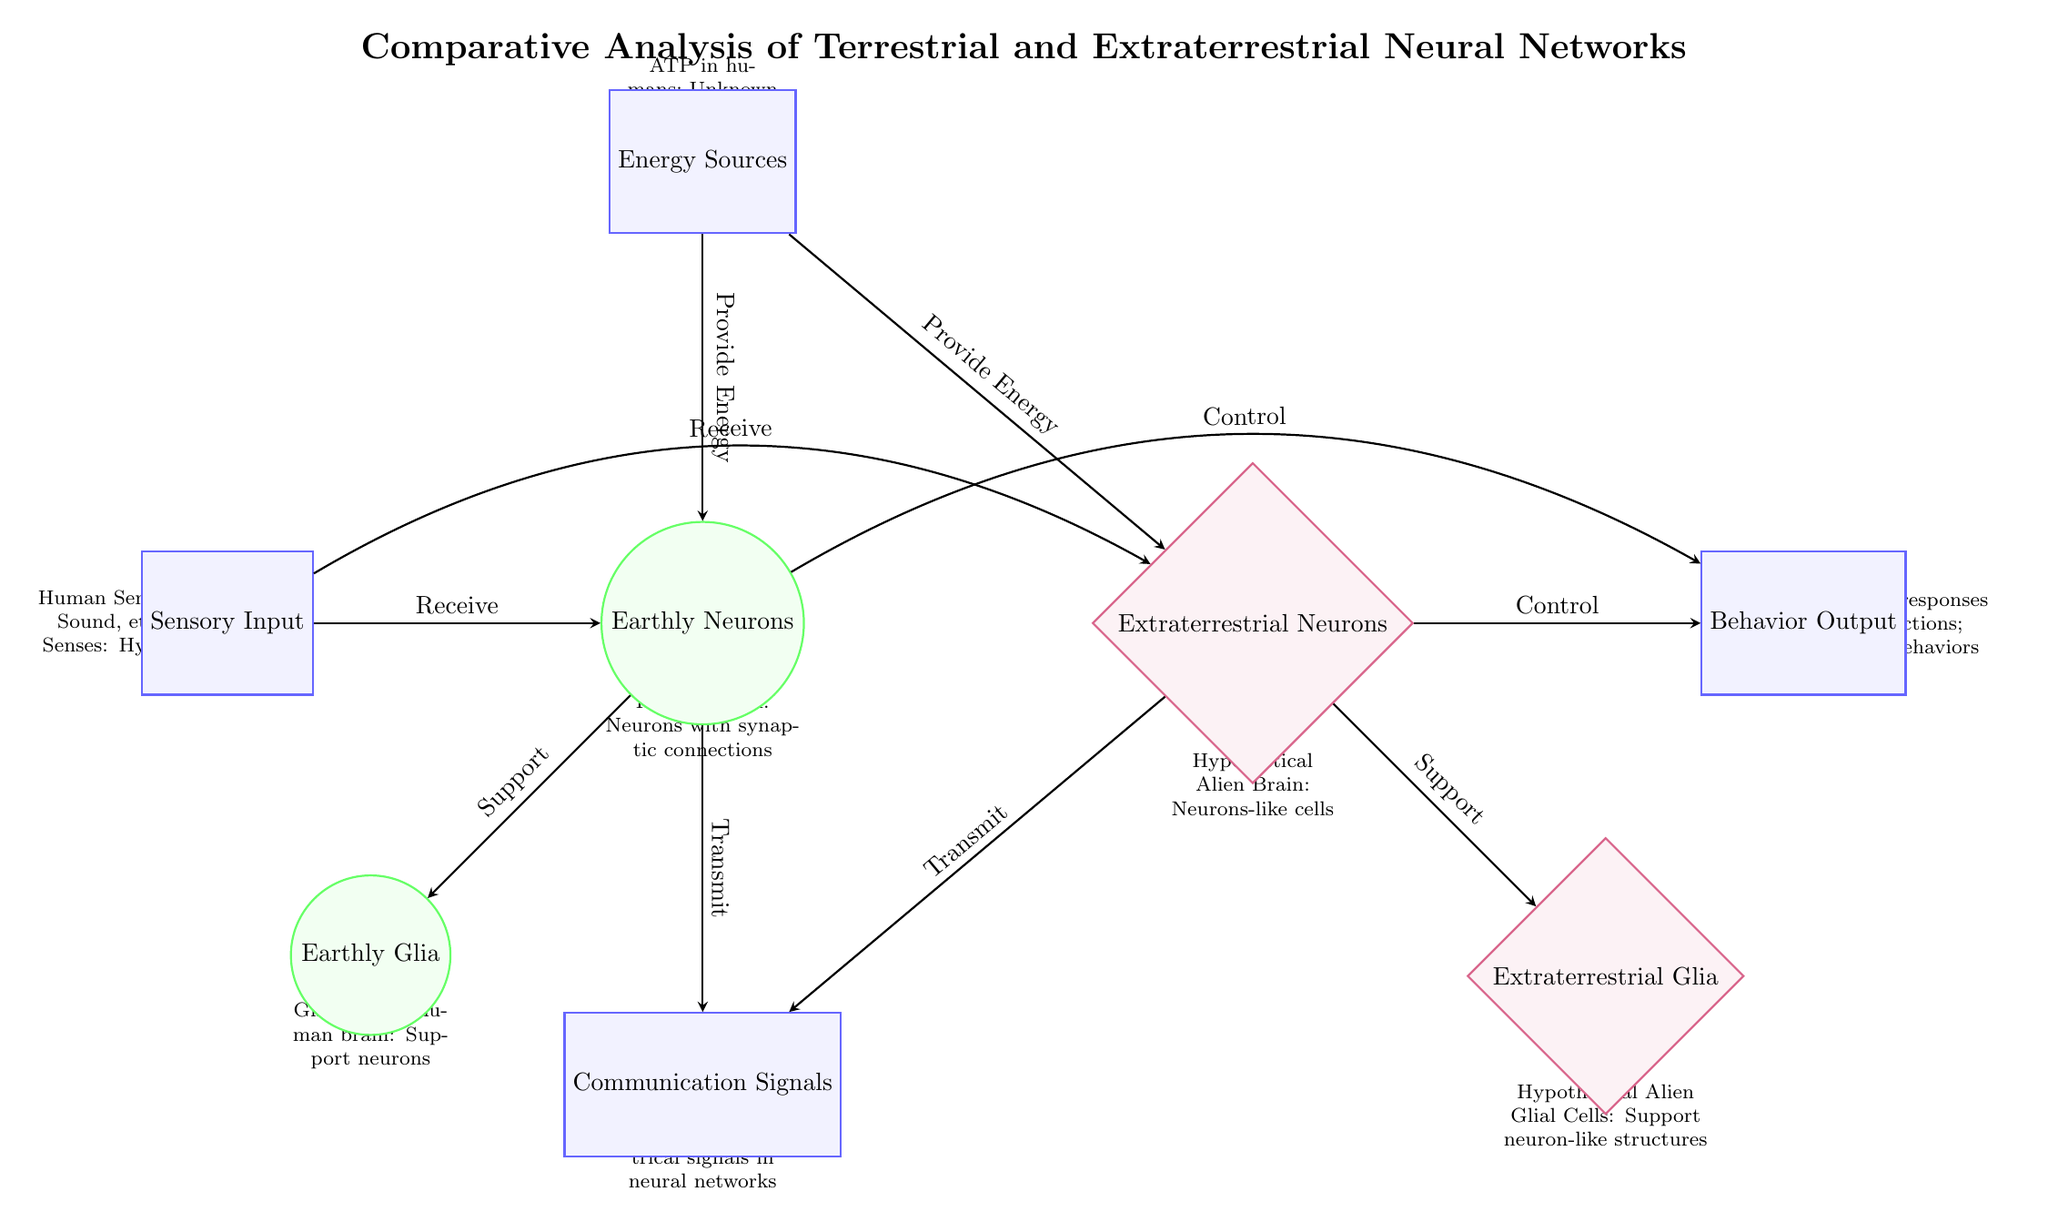What are the two types of neurons depicted in the diagram? The diagram shows two types of neurons: Earthly Neurons and Extraterrestrial Neurons.
Answer: Earthly Neurons, Extraterrestrial Neurons Which node represents the energy sources? The node labeled "Energy Sources" is positioned above the Earthly Neurons node.
Answer: Energy Sources How many support relationships are indicated in the diagram? There are two support relationships: one from Earthly Neurons to Earthly Glia and another from Extraterrestrial Neurons to Extraterrestrial Glia, totaling two.
Answer: 2 What type of input is received by both terrestrial and extraterrestrial neurons? Both types of neurons receive "Sensory Input," as indicated by the edges connecting to both the Earthly Neurons and the Extraterrestrial Neurons.
Answer: Sensory Input What is the primary output behavior of the neurons shown? The primary output behavior is indicated as "Behavior Output," which both neuron types control based on connections leading from them.
Answer: Behavior Output What two components are required for energy provision to both neuron types? Both neuron types require energy sources: "ATP in humans" and "Unknown molecules in aliens," as shown in the Energy Sources node.
Answer: ATP in humans; Unknown molecules in aliens How do earthly and extraterrestrial neurons transmit signals? Both terrestrial and extraterrestrial neurons transmit through "Communication Signals," as shown by the connections coming from both neuron types.
Answer: Communication Signals What structural type do extraterrestrial glial cells share with earthly glial cells? The diagram indicates that both earthly glial cells and extraterrestrial glial cells support their respective neurons, establishing a similarity in their structural function.
Answer: Support neuron-like structures 